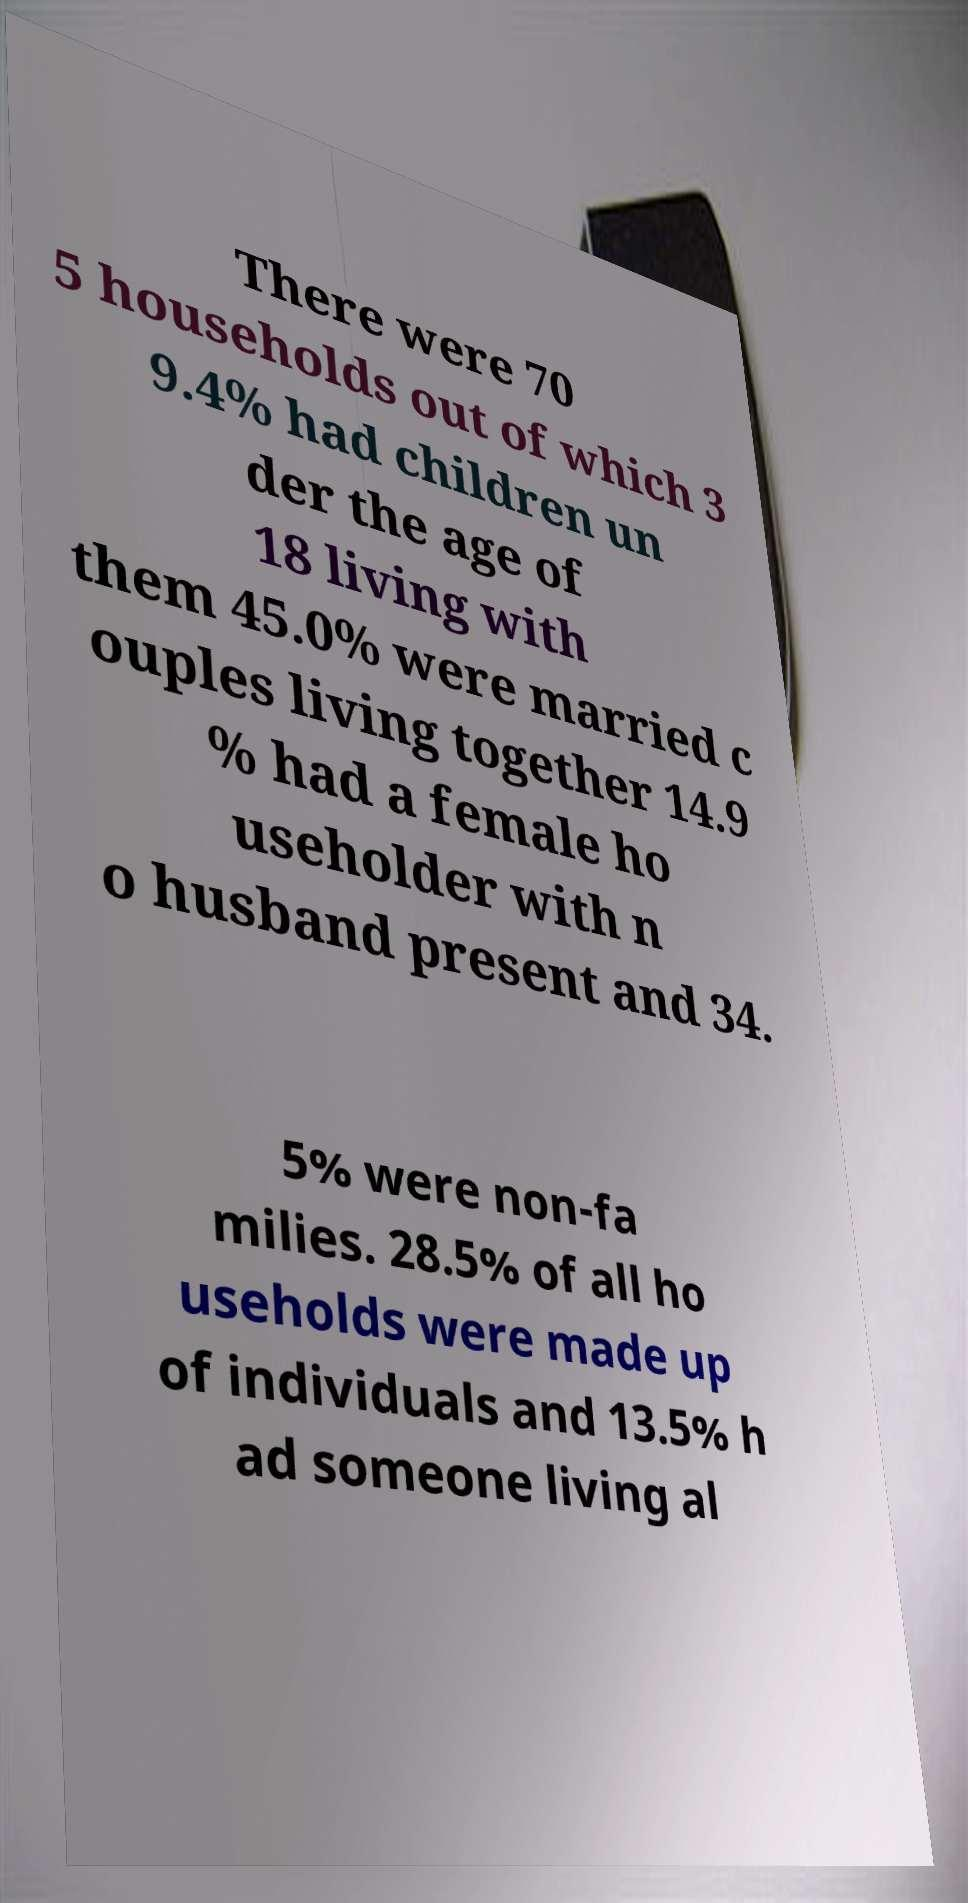Please read and relay the text visible in this image. What does it say? There were 70 5 households out of which 3 9.4% had children un der the age of 18 living with them 45.0% were married c ouples living together 14.9 % had a female ho useholder with n o husband present and 34. 5% were non-fa milies. 28.5% of all ho useholds were made up of individuals and 13.5% h ad someone living al 